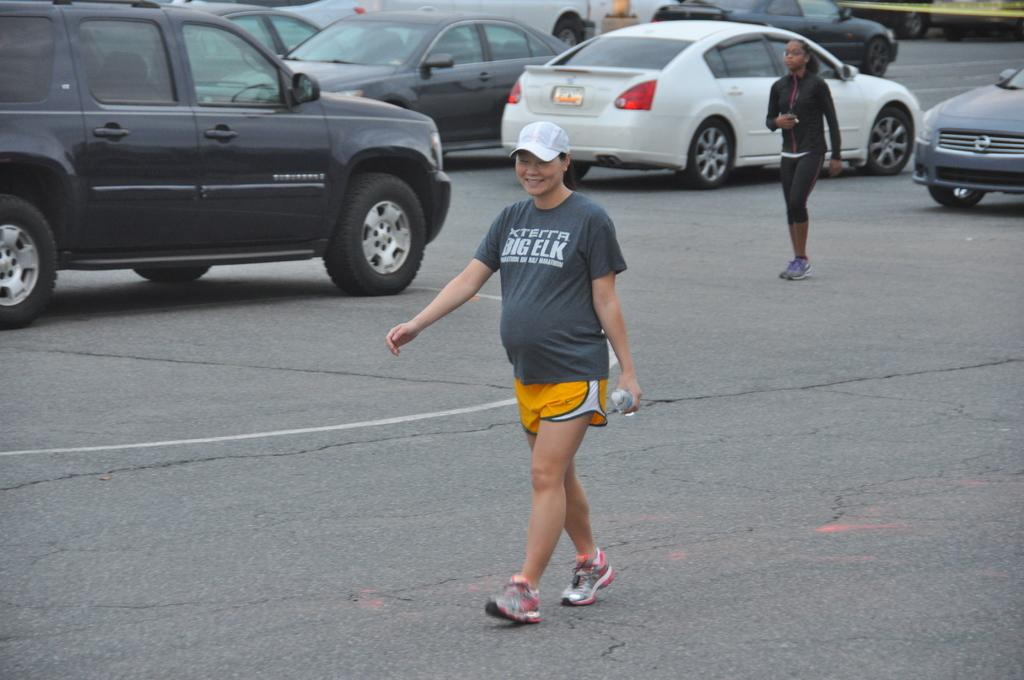What are the women in the image doing? The women in the image are walking. What are the women wearing? The women are wearing clothes and shoes. Can you describe the woman with the cap? The woman with the cap is holding a bottle in her hand. What else can be seen in the image? There are vehicles and a road in the image. Where is the oven located in the image? There is no oven present in the image. What type of cakes are being baked in the cemetery in the image? There is no cemetery or cakes present in the image. 